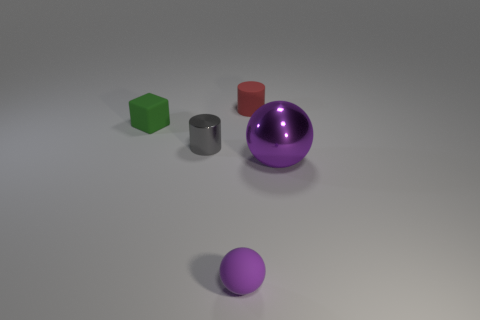Add 2 small brown metal things. How many objects exist? 7 Subtract all blocks. How many objects are left? 4 Add 3 big blue cubes. How many big blue cubes exist? 3 Subtract 0 gray spheres. How many objects are left? 5 Subtract all brown blocks. Subtract all small balls. How many objects are left? 4 Add 2 rubber balls. How many rubber balls are left? 3 